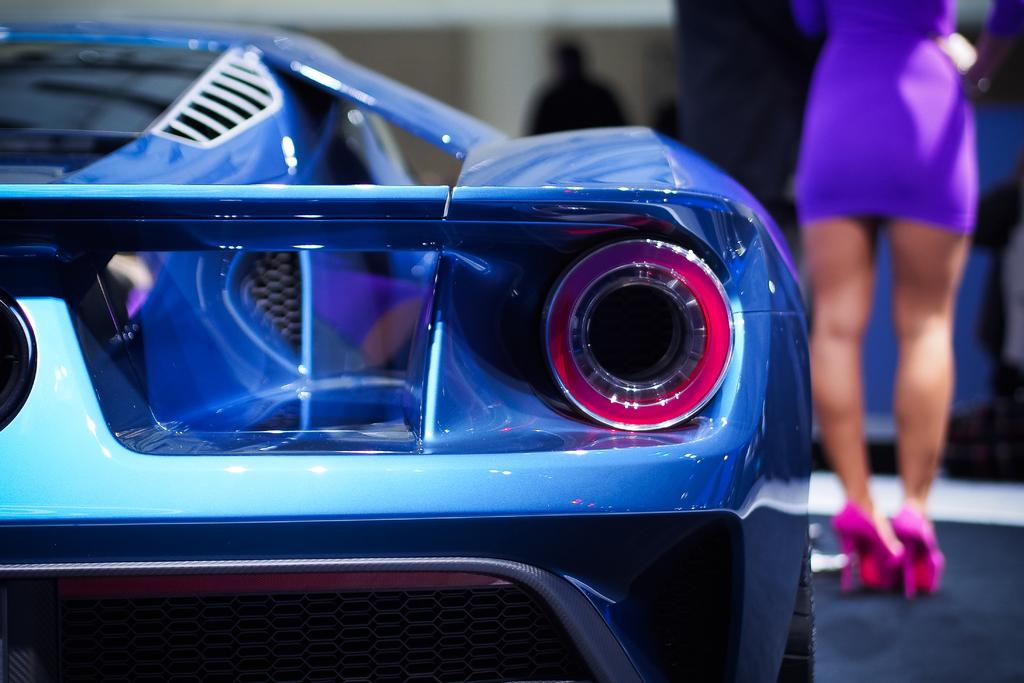What is the main subject of the image? There is a car in the image. Can you describe the person in the image? A person is standing on the right side of the car. What can be observed about the background in the image? The background behind the car is blurred. What type of basket is the goat carrying on the left side of the car? There is no goat or basket present in the image. 